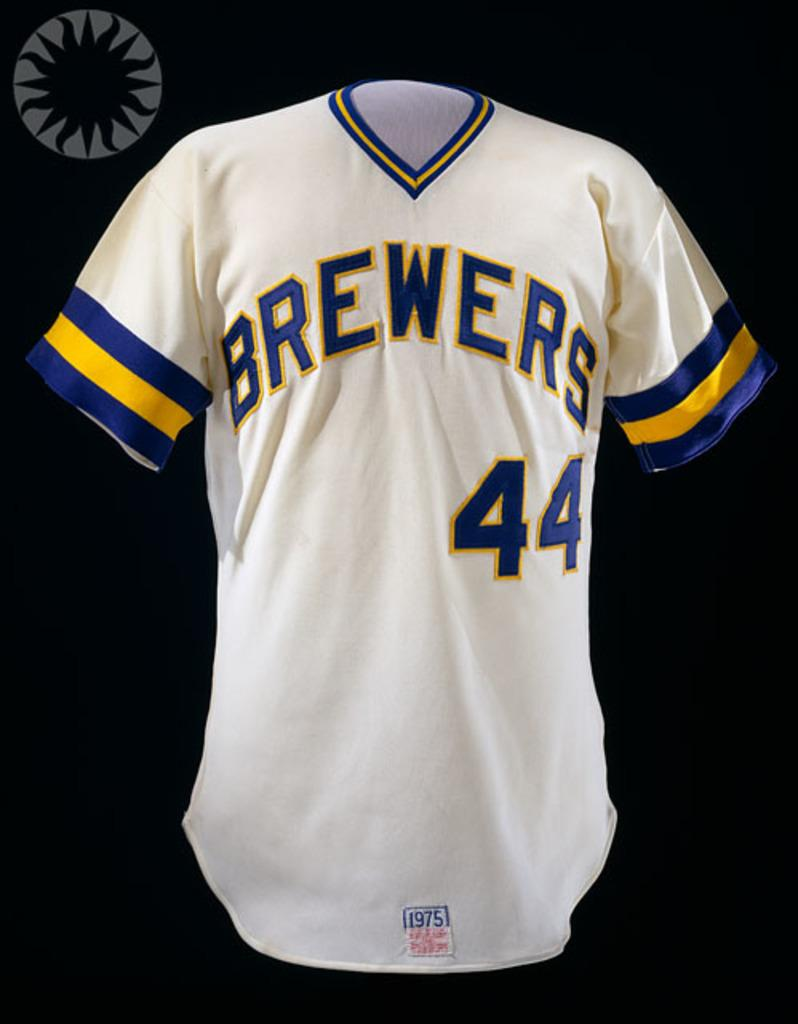<image>
Present a compact description of the photo's key features. A blue and yellow striped white jersey displaying Brewers with the number forty-four on it. 